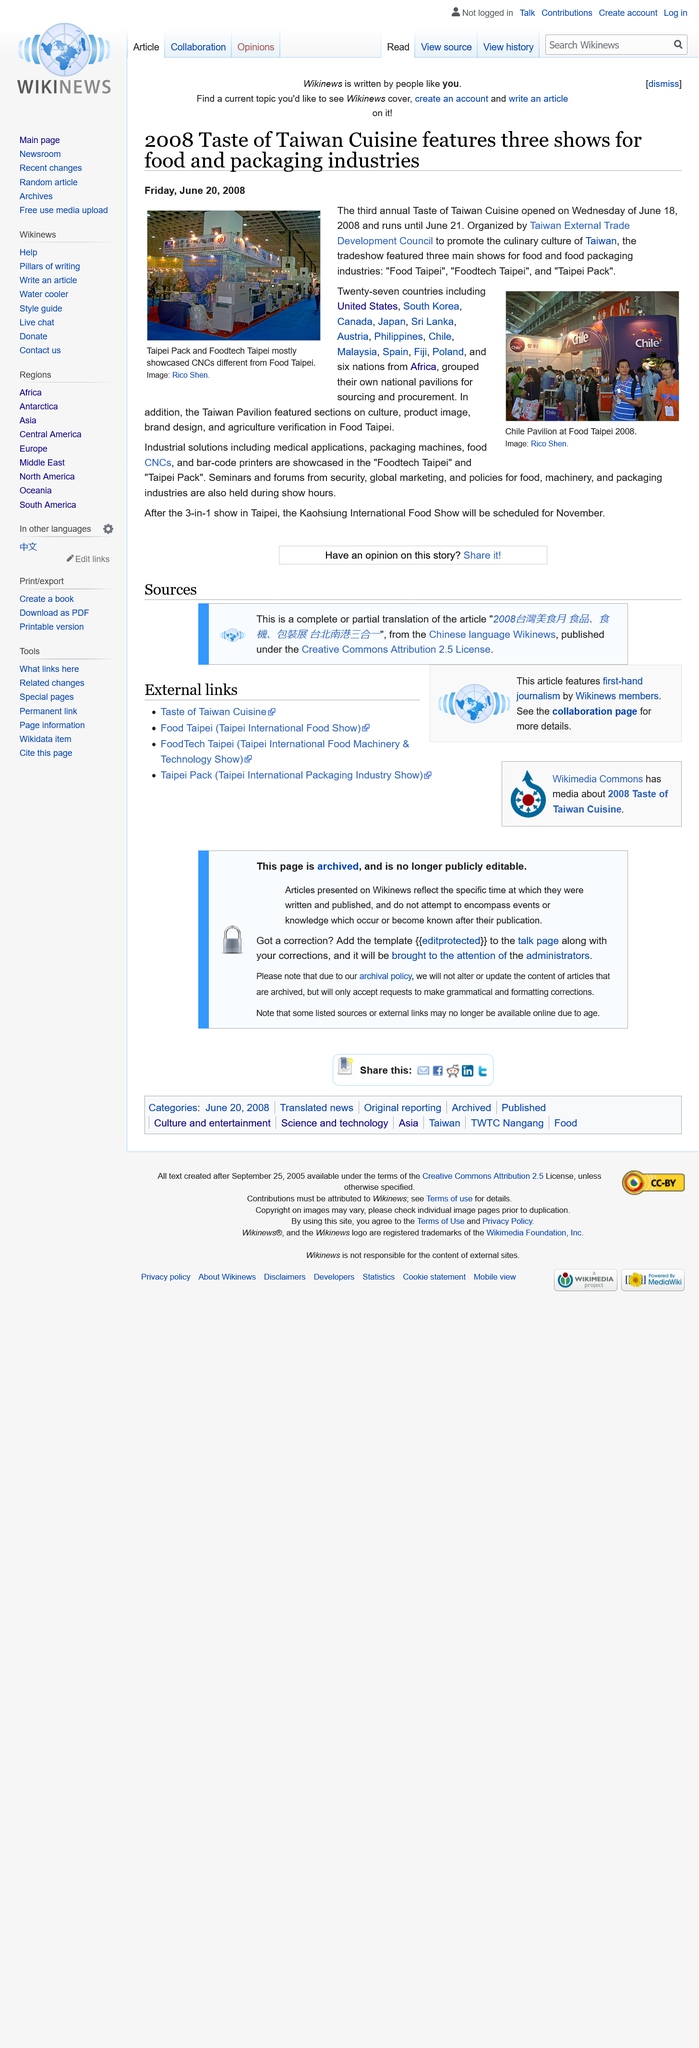Highlight a few significant elements in this photo. The third annual Taste of Taiwan Cuisine opened on June 18, 2008 and ran until June 21, 2008, during which time it showcased the best of Taiwanese cuisine. The image on the right depicts the Chile Pavilion at Food Taipei 2008, which displays various products and promotional materials related to Chilean agriculture and food industry. A total of 27 countries, in addition to Taiwan, had their own national pavilions at the Asia Fruit Logistica 2021 trade show, showcasing their fresh fruit and vegetable products to potential buyers. 